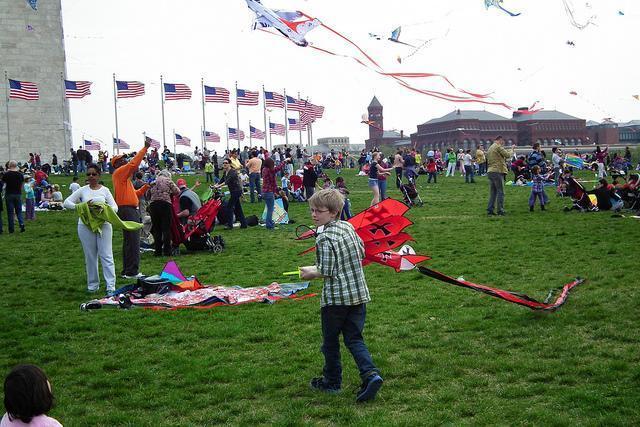How many people are in the photo?
Give a very brief answer. 5. How many kites can you see?
Give a very brief answer. 2. How many cars have a surfboard on the roof?
Give a very brief answer. 0. 